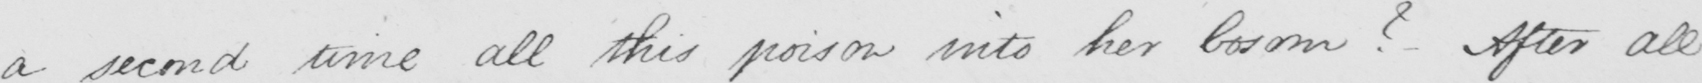Please provide the text content of this handwritten line. a second time all poison into her bosom ?   _  After all 